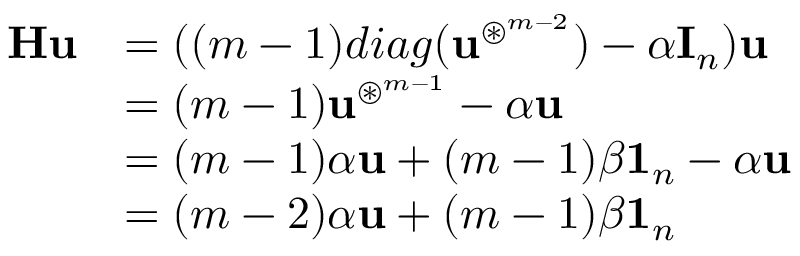<formula> <loc_0><loc_0><loc_500><loc_500>\begin{array} { r l } { \mathbf H \mathbf u } & { = ( ( m - 1 ) d i a g ( \mathbf u ^ { \circledast ^ { m - 2 } } ) - \alpha \mathbf I _ { n } ) \mathbf u } \\ & { = ( m - 1 ) \mathbf u ^ { \circledast ^ { m - 1 } } - \alpha \mathbf u } \\ & { = ( m - 1 ) \alpha \mathbf u + ( m - 1 ) \beta \mathbf 1 _ { n } - \alpha \mathbf u } \\ & { = ( m - 2 ) \alpha \mathbf u + ( m - 1 ) \beta \mathbf 1 _ { n } } \end{array}</formula> 